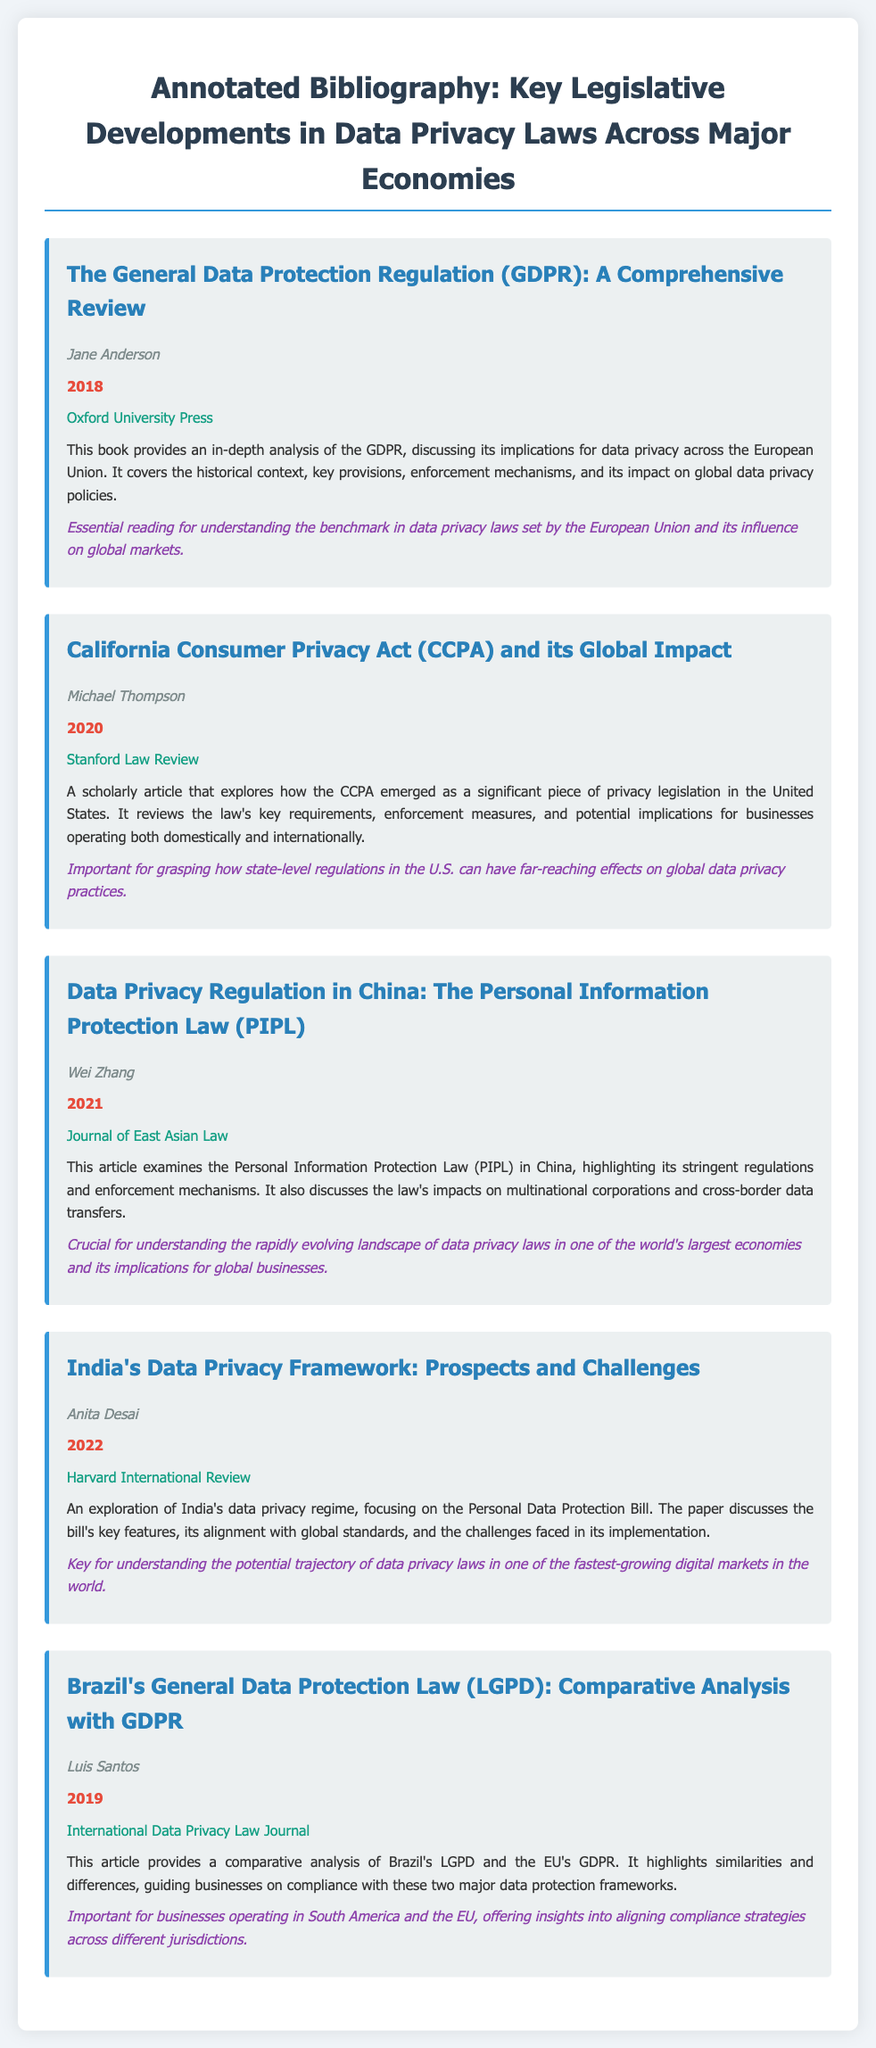What is the title of the first entry? The title of the first entry is given in the document under the heading, which states "The General Data Protection Regulation (GDPR): A Comprehensive Review".
Answer: The General Data Protection Regulation (GDPR): A Comprehensive Review Who is the author of the article on China's data privacy regulation? The author is identified in the document as Wei Zhang, specifically mentioned in the entry about the Personal Information Protection Law (PIPL) in China.
Answer: Wei Zhang What year was the California Consumer Privacy Act (CCPA) article published? The publication year is stated within the entry, which indicates it was published in 2020.
Answer: 2020 Which publisher released the book on GDPR? The publisher's name is mentioned in the entry related to the GDPR, which lists Oxford University Press as the publisher.
Answer: Oxford University Press What is the main focus of Anita Desai's article? The summary of the entry clarifies that Anita Desai's article primarily explores India's data privacy regime and the Personal Data Protection Bill.
Answer: India's data privacy regime: Prospects and Challenges How many entries are listed in the document? The document contains a total of five entries related to key legislative developments in data privacy laws across major economies.
Answer: Five Which law does Luis Santos compare to Brazil's LGPD? The document specifies that the comparative analysis presented by Luis Santos is between Brazil's LGPD and the EU's GDPR.
Answer: GDPR What is the relevance of the CCPA article in the context of global data privacy? The relevance section highlights that understanding the CCPA is significant for grasping the effects of state-level regulations on international data privacy practices.
Answer: Effects on global data privacy practices 